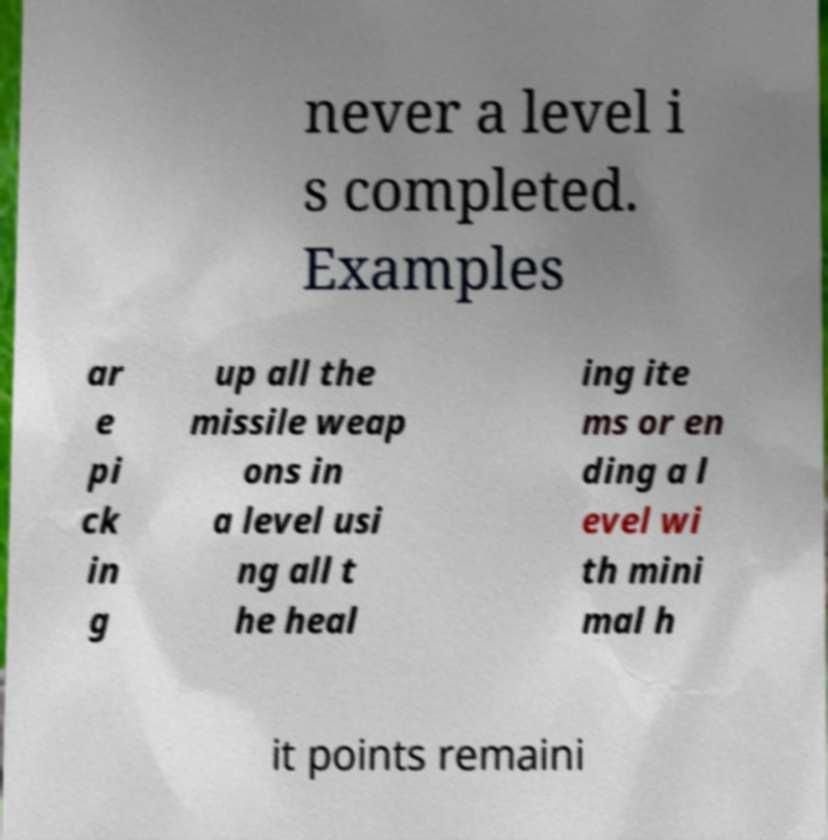There's text embedded in this image that I need extracted. Can you transcribe it verbatim? never a level i s completed. Examples ar e pi ck in g up all the missile weap ons in a level usi ng all t he heal ing ite ms or en ding a l evel wi th mini mal h it points remaini 